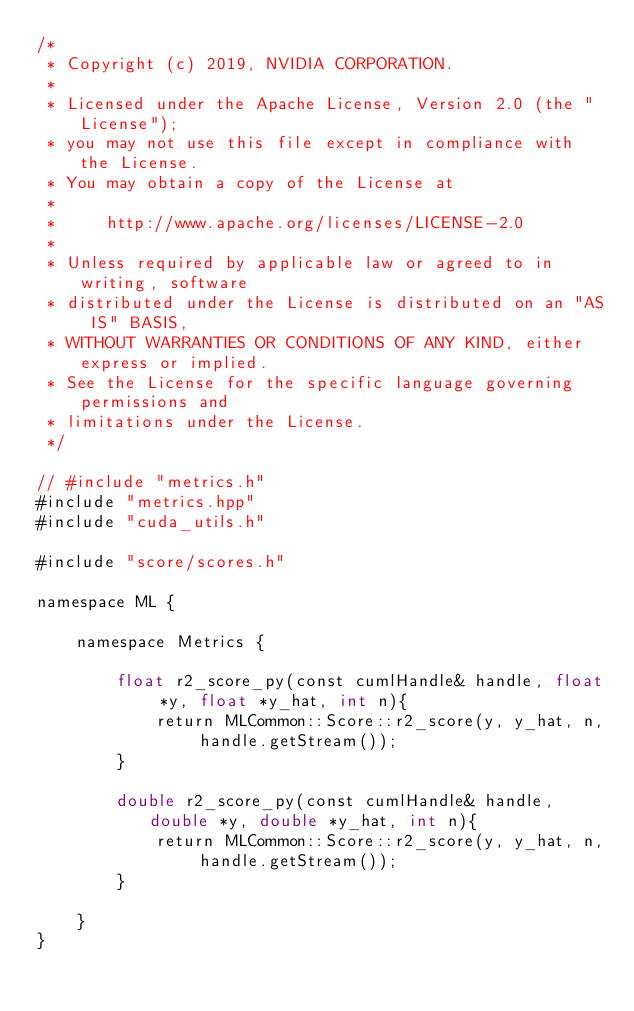Convert code to text. <code><loc_0><loc_0><loc_500><loc_500><_Cuda_>/*
 * Copyright (c) 2019, NVIDIA CORPORATION.
 *
 * Licensed under the Apache License, Version 2.0 (the "License");
 * you may not use this file except in compliance with the License.
 * You may obtain a copy of the License at
 *
 *     http://www.apache.org/licenses/LICENSE-2.0
 *
 * Unless required by applicable law or agreed to in writing, software
 * distributed under the License is distributed on an "AS IS" BASIS,
 * WITHOUT WARRANTIES OR CONDITIONS OF ANY KIND, either express or implied.
 * See the License for the specific language governing permissions and
 * limitations under the License.
 */

// #include "metrics.h"
#include "metrics.hpp"
#include "cuda_utils.h"

#include "score/scores.h"

namespace ML {

    namespace Metrics {

        float r2_score_py(const cumlHandle& handle, float *y, float *y_hat, int n){
            return MLCommon::Score::r2_score(y, y_hat, n, handle.getStream());
        }

        double r2_score_py(const cumlHandle& handle, double *y, double *y_hat, int n){
            return MLCommon::Score::r2_score(y, y_hat, n, handle.getStream());
        }

    }
}
</code> 